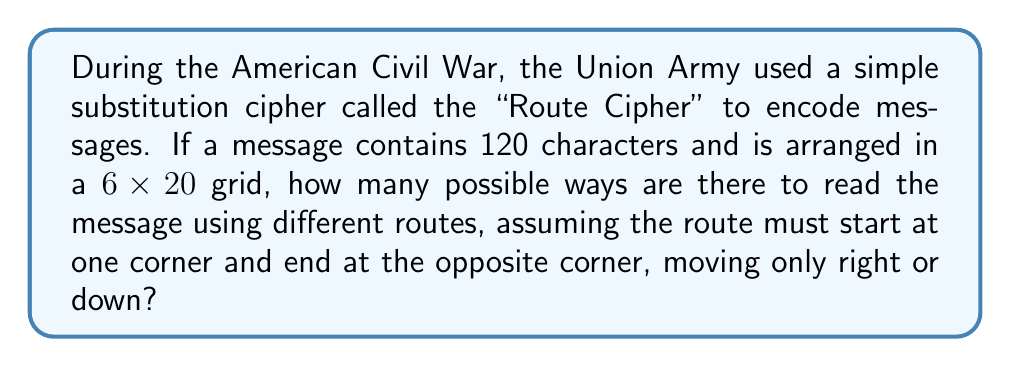Teach me how to tackle this problem. Let's approach this step-by-step:

1) First, we need to understand the grid:
   - It's 6 rows by 20 columns
   - We start at one corner (top-left) and end at the opposite corner (bottom-right)
   - We can only move right or down

2) This problem is equivalent to finding the number of paths from the top-left to the bottom-right corner of a 6x20 grid.

3) To reach the bottom-right corner, we must:
   - Move right 19 times (to cover 20 columns)
   - Move down 5 times (to cover 6 rows)

4) The total number of moves is always 19 + 5 = 24

5) The question is essentially asking: in how many ways can we arrange 19 right moves and 5 down moves?

6) This is a combination problem. We need to choose positions for either the right moves or the down moves out of the total 24 moves.

7) We can calculate this using the combination formula:

   $$\binom{24}{19} = \binom{24}{5} = \frac{24!}{19!5!}$$

8) Calculating this:
   $$\frac{24!}{19!5!} = \frac{24 \times 23 \times 22 \times 21 \times 20}{5 \times 4 \times 3 \times 2 \times 1} = 42,504$$

Therefore, there are 42,504 possible ways to read the message using different routes.
Answer: 42,504 